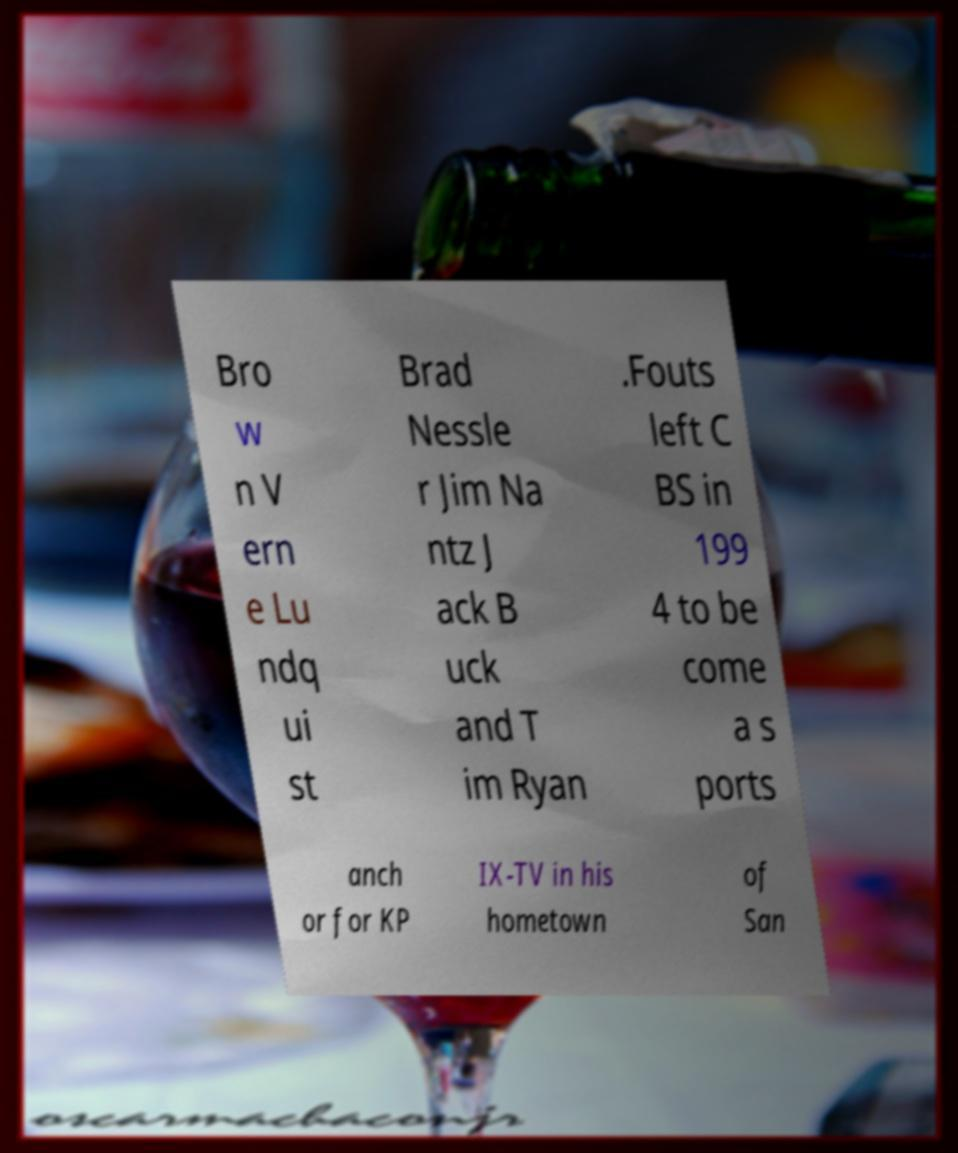There's text embedded in this image that I need extracted. Can you transcribe it verbatim? Bro w n V ern e Lu ndq ui st Brad Nessle r Jim Na ntz J ack B uck and T im Ryan .Fouts left C BS in 199 4 to be come a s ports anch or for KP IX-TV in his hometown of San 